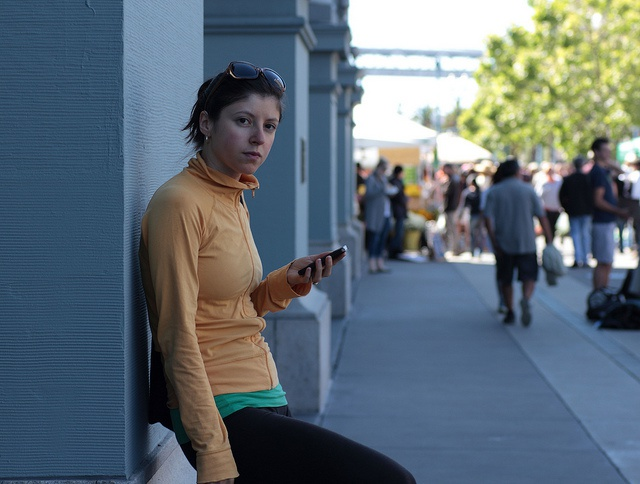Describe the objects in this image and their specific colors. I can see people in blue, black, gray, and maroon tones, people in blue, gray, darkgray, black, and lightgray tones, people in blue, black, navy, darkblue, and gray tones, people in blue, black, gray, navy, and darkblue tones, and people in blue, black, and gray tones in this image. 